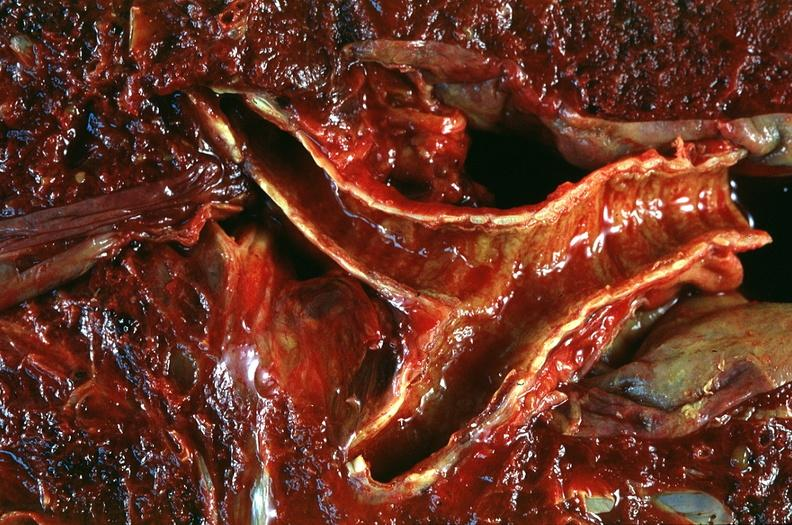s cervix duplication present?
Answer the question using a single word or phrase. No 